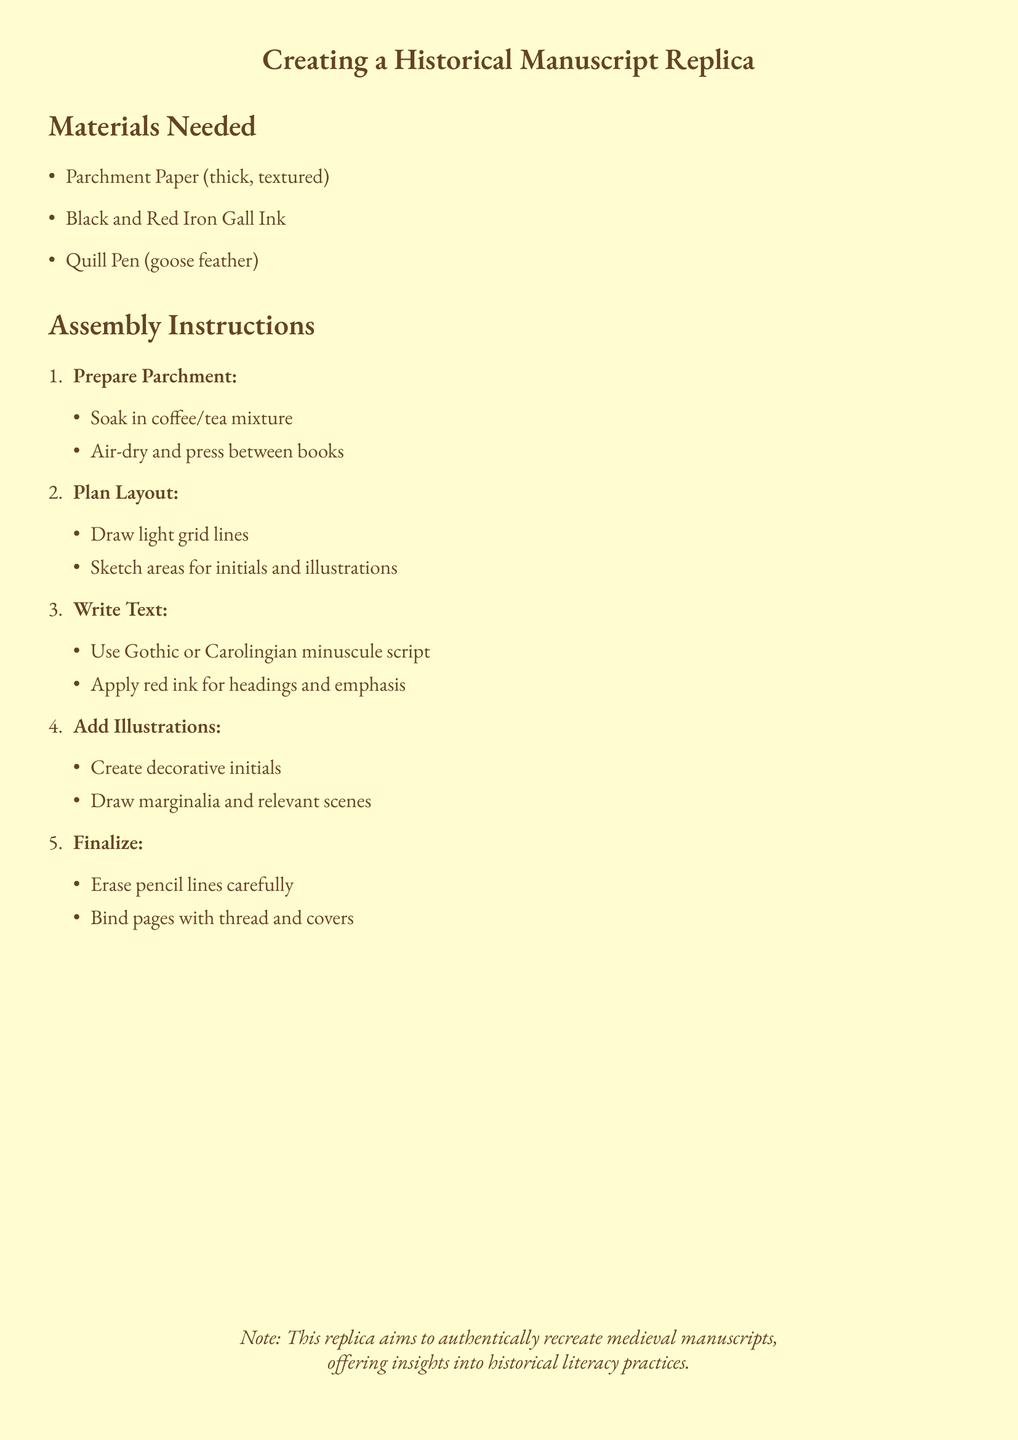What is the main title of the document? The main title is stated at the center of the document, presenting the subject of the assembly instructions.
Answer: Creating a Historical Manuscript Replica How many materials are listed in the document? The document lists three specific materials required for the project, found in the "Materials Needed" section.
Answer: 3 What is the first step in the assembly instructions? The first action outlined in the assembly section focuses on preparing the parchment, emphasizing the initial procedure of the project.
Answer: Prepare Parchment What type of ink is recommended for writing? The document mentions specific types of ink to be used while writing, which are critical to replicating the historical manuscript accurately.
Answer: Black and Red Iron Gall Ink What is used to write the text? The document specifies the writing instrument crucial for the manuscript creation, which reflects medieval practices.
Answer: Quill Pen What script styles should be used for writing? The document provides guidance on the appropriate writing style for the text, indicating historical accuracy in replication.
Answer: Gothic or Carolingian minuscule script What should be created alongside the text? As part of adding creativity and historical context to the manuscript, the document mentions a specific element that complements the written text.
Answer: Illustrations What final step does the document suggest? The last instruction focuses on finishing touches to ensure the manuscript's completeness and durability, indicating an important concluding action.
Answer: Finalize What does the note at the bottom aim to convey? The note provides context for the purpose behind creating the manuscript replica, emphasizing its educational significance.
Answer: Insights into historical literacy practices 